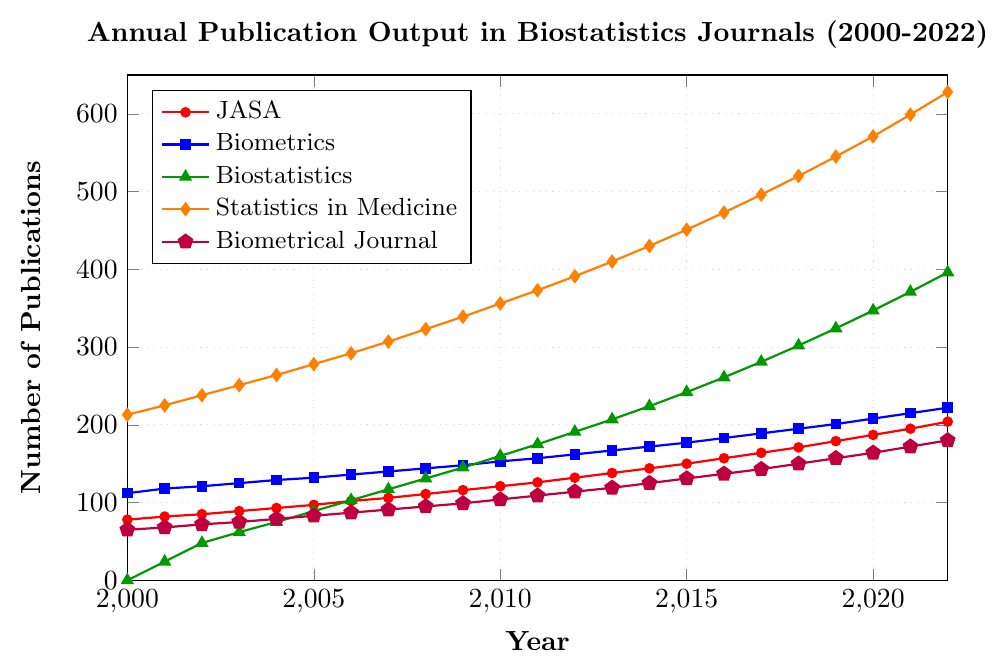How many publications were there in 2010 for "Statistics in Medicine"? Locate the year 2010 on the x-axis and trace up to the "Statistics in Medicine" plot (orange line). The corresponding y-value is 356.
Answer: 356 Which journal had the highest number of publications in 2022? Locate the year 2022 on the x-axis and trace the corresponding y-values for each journal. "Statistics in Medicine" (red line) peaks the highest with 628 publications.
Answer: Statistics in Medicine Between which years did the "Journal of the American Statistical Association" see the maximum increase in publications? Compare the publications year-wise for "Journal of the American Statistical Association" (red line). The largest increase occurred between 2018 (171) and 2019 (179), an increase of 8 publications.
Answer: Between 2018 and 2019 How does the trend of "Biostatistics" compare to that of "Biometrical Journal" over the years? Observe both plots for "Biostatistics" (green) and "Biometrical Journal" (purple). Notice "Biostatistics" starts from 0 in 2000 and shows steady growth, surpassing "Biometrical Journal" in mid-2000s and continuing to grow faster.
Answer: "Biostatistics" shows a steeper upward trend compared to the more gradual increase in "Biometrical Journal." Which journal had the least number of publications in 2000 and how many were there? Locate the year 2000 and compare the y-values for each journal. "Biostatistics" had 0 publications.
Answer: Biostatistics, 0 What is the average number of publications in 2022 for all journals combined? Sum the publications for 2022 from all journals: 204 (JASA) + 222 (Biometrics) + 396 (Biostatistics) + 628 (Statistics in Medicine) + 180 (Biometrical Journal) = 1630. Divide by 5 journals: 1630/5 = 326.
Answer: 326 By how much did the publications in "Statistics in Medicine" increase from 2010 to 2022? Find the values in 2010 and 2022 for "Statistics in Medicine" (red line): 356 (2010) and 628 (2022). The increase is 628 - 356 = 272.
Answer: 272 Which journal surpassed 100 publications first and in which year? Checking each journal in early years, "Biometrics" surpassed 100 publications first in the year 2000, reaching 112.
Answer: Biometrics, 2000 